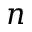Convert formula to latex. <formula><loc_0><loc_0><loc_500><loc_500>{ \boldsymbol n }</formula> 